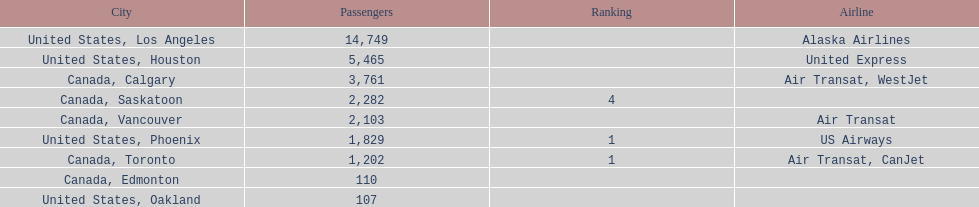Was los angeles or houston the busiest international route at manzanillo international airport in 2013? Los Angeles. 